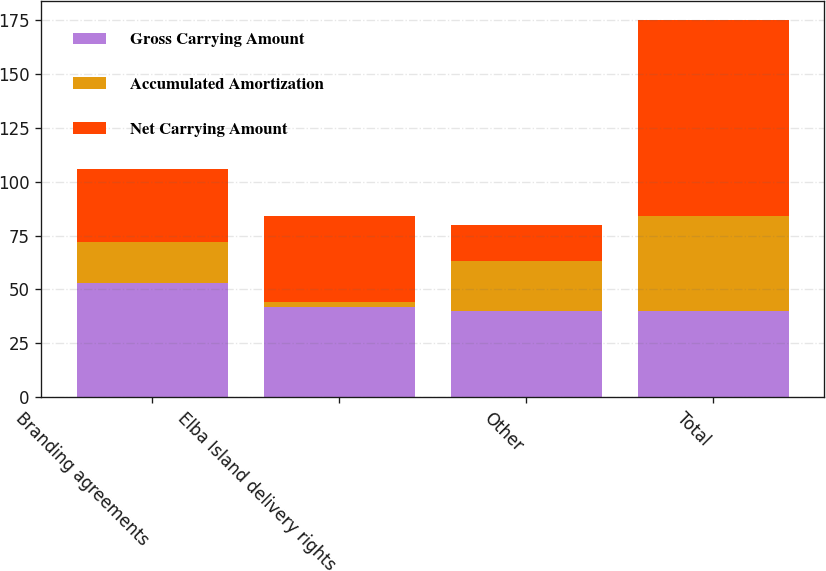Convert chart. <chart><loc_0><loc_0><loc_500><loc_500><stacked_bar_chart><ecel><fcel>Branding agreements<fcel>Elba Island delivery rights<fcel>Other<fcel>Total<nl><fcel>Gross Carrying Amount<fcel>53<fcel>42<fcel>40<fcel>40<nl><fcel>Accumulated Amortization<fcel>19<fcel>2<fcel>23<fcel>44<nl><fcel>Net Carrying Amount<fcel>34<fcel>40<fcel>17<fcel>91<nl></chart> 